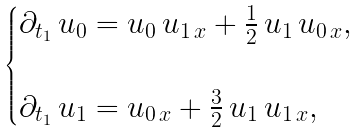<formula> <loc_0><loc_0><loc_500><loc_500>\begin{cases} \partial _ { t _ { 1 } } \, u _ { 0 } = u _ { 0 } \, u _ { 1 \, x } + \frac { 1 } { 2 } \, u _ { 1 } \, u _ { 0 \, x } , \\ \\ \partial _ { t _ { 1 } } \, u _ { 1 } = u _ { 0 \, x } + \frac { 3 } { 2 } \, u _ { 1 } \, u _ { 1 \, x } , \end{cases}</formula> 